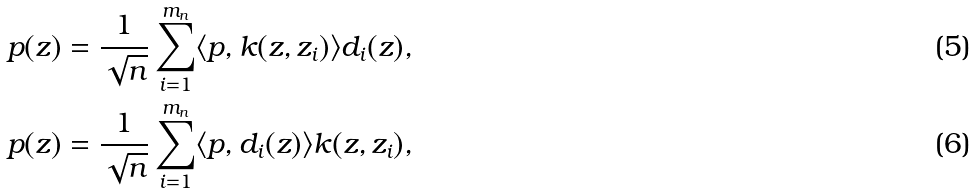Convert formula to latex. <formula><loc_0><loc_0><loc_500><loc_500>p ( z ) = \frac { 1 } { \sqrt { n } } \sum _ { i = 1 } ^ { m _ { n } } \langle p , k ( z , z _ { i } ) \rangle d _ { i } ( z ) , \\ p ( z ) = \frac { 1 } { \sqrt { n } } \sum _ { i = 1 } ^ { m _ { n } } \langle p , d _ { i } ( z ) \rangle k ( z , z _ { i } ) ,</formula> 